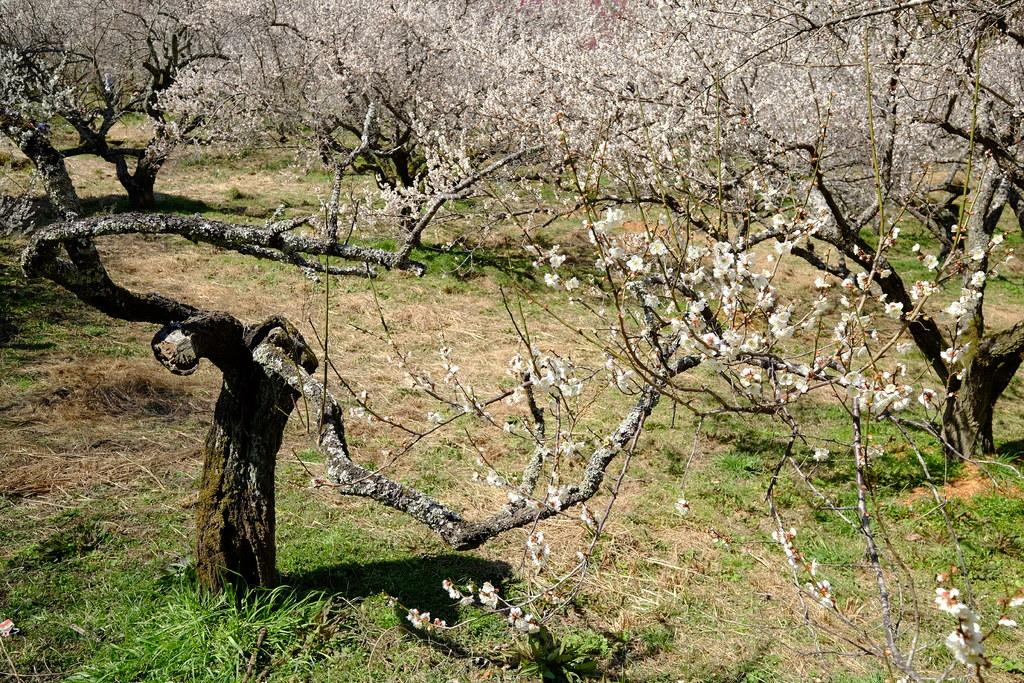What type of flowers are present in the image? There are white color flowers in the image. What other natural elements can be seen in the image? There are trees and green grass visible in the image. What type of window can be seen in the image? There is no window present in the image; it features flowers, trees, and green grass. What industry is depicted in the image? The image does not depict any specific industry; it focuses on natural elements like flowers, trees, and green grass. 